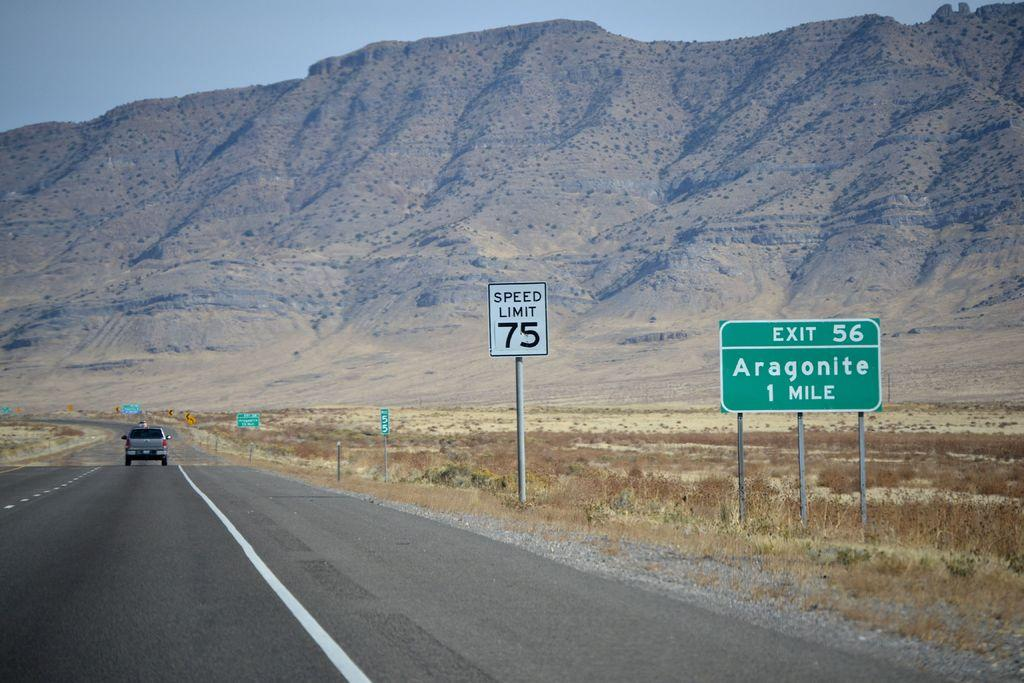<image>
Create a compact narrative representing the image presented. Signs on an interstate for exit 56 to Aragonite indicating it's one mile away. 